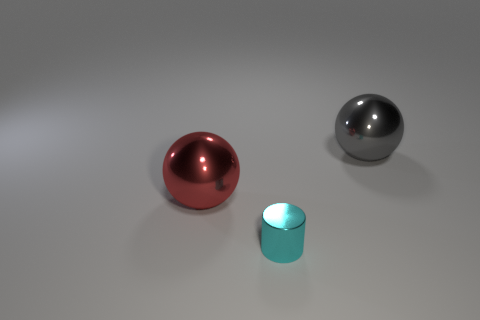Add 3 red things. How many objects exist? 6 Subtract all balls. How many objects are left? 1 Subtract 0 gray cylinders. How many objects are left? 3 Subtract 1 balls. How many balls are left? 1 Subtract all blue cylinders. Subtract all cyan spheres. How many cylinders are left? 1 Subtract all purple cubes. How many yellow cylinders are left? 0 Subtract all tiny matte cylinders. Subtract all red metal spheres. How many objects are left? 2 Add 3 big gray metallic spheres. How many big gray metallic spheres are left? 4 Add 2 big red matte spheres. How many big red matte spheres exist? 2 